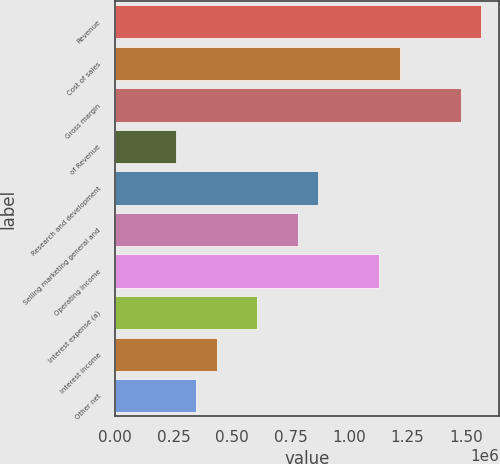Convert chart to OTSL. <chart><loc_0><loc_0><loc_500><loc_500><bar_chart><fcel>Revenue<fcel>Cost of sales<fcel>Gross margin<fcel>of Revenue<fcel>Research and development<fcel>Selling marketing general and<fcel>Operating income<fcel>Interest expense (a)<fcel>Interest income<fcel>Other net<nl><fcel>1.56526e+06<fcel>1.21743e+06<fcel>1.4783e+06<fcel>260878<fcel>869591<fcel>782632<fcel>1.13047e+06<fcel>608714<fcel>434796<fcel>347837<nl></chart> 